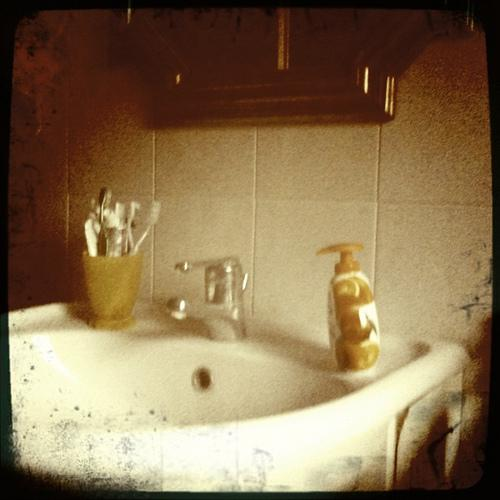Question: why is there soap?
Choices:
A. To bathe.
B. To wash hands.
C. To wash dishes.
D. To wash face.
Answer with the letter. Answer: B Question: what is on the wall?
Choices:
A. Picture.
B. Light fixture.
C. Mirror.
D. Speakers.
Answer with the letter. Answer: C Question: how many sinks?
Choices:
A. 1.
B. 2.
C. 3.
D. 4.
Answer with the letter. Answer: A 